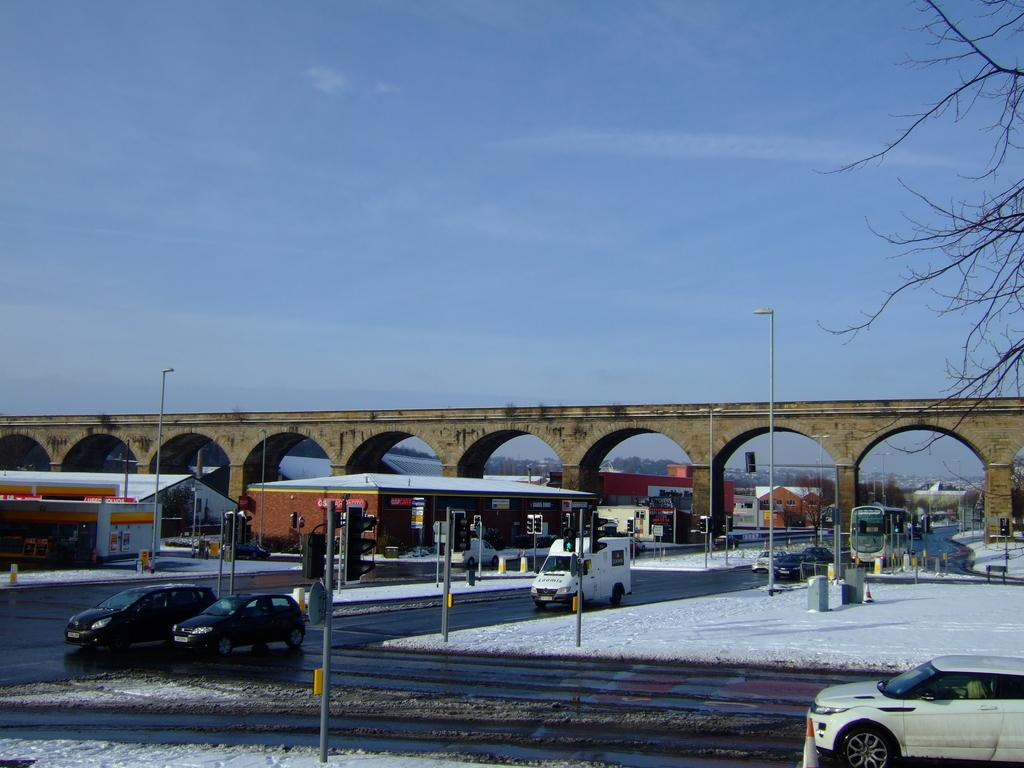What can be seen on the road in the image? There are vehicles on the road in the image. What helps regulate traffic in the image? There are traffic signals in the image. What structures are present near the road in the image? There are electric poles and sheds in the image. What objects are visible in the image? There are objects in the image, but their specific nature is not mentioned in the facts. What can be seen in the distance in the image? There is a bridge visible in the background of the image. What type of natural elements are visible in the background of the image? There are trees and the sky visible in the background of the image. Can you see a rod being used by a scarecrow in the image? There is no rod or scarecrow present in the image. What type of mitten is being worn by the person driving the vehicle in the image? There is no person or mitten visible in the image. 